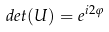<formula> <loc_0><loc_0><loc_500><loc_500>d e t ( U ) = e ^ { i 2 \varphi }</formula> 